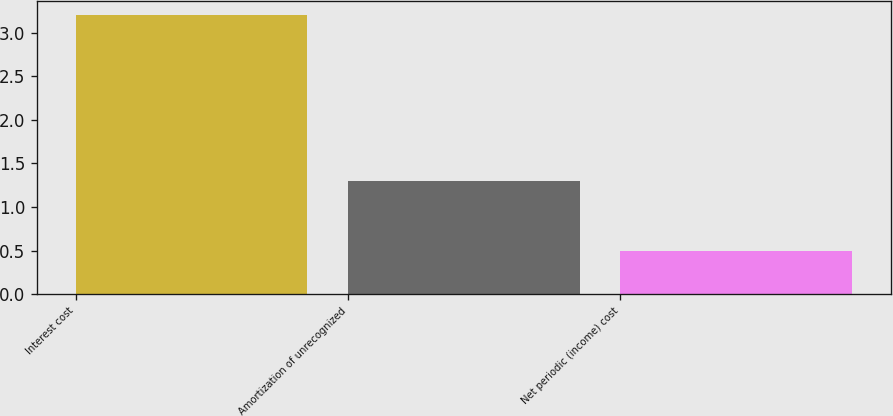<chart> <loc_0><loc_0><loc_500><loc_500><bar_chart><fcel>Interest cost<fcel>Amortization of unrecognized<fcel>Net periodic (income) cost<nl><fcel>3.2<fcel>1.3<fcel>0.5<nl></chart> 